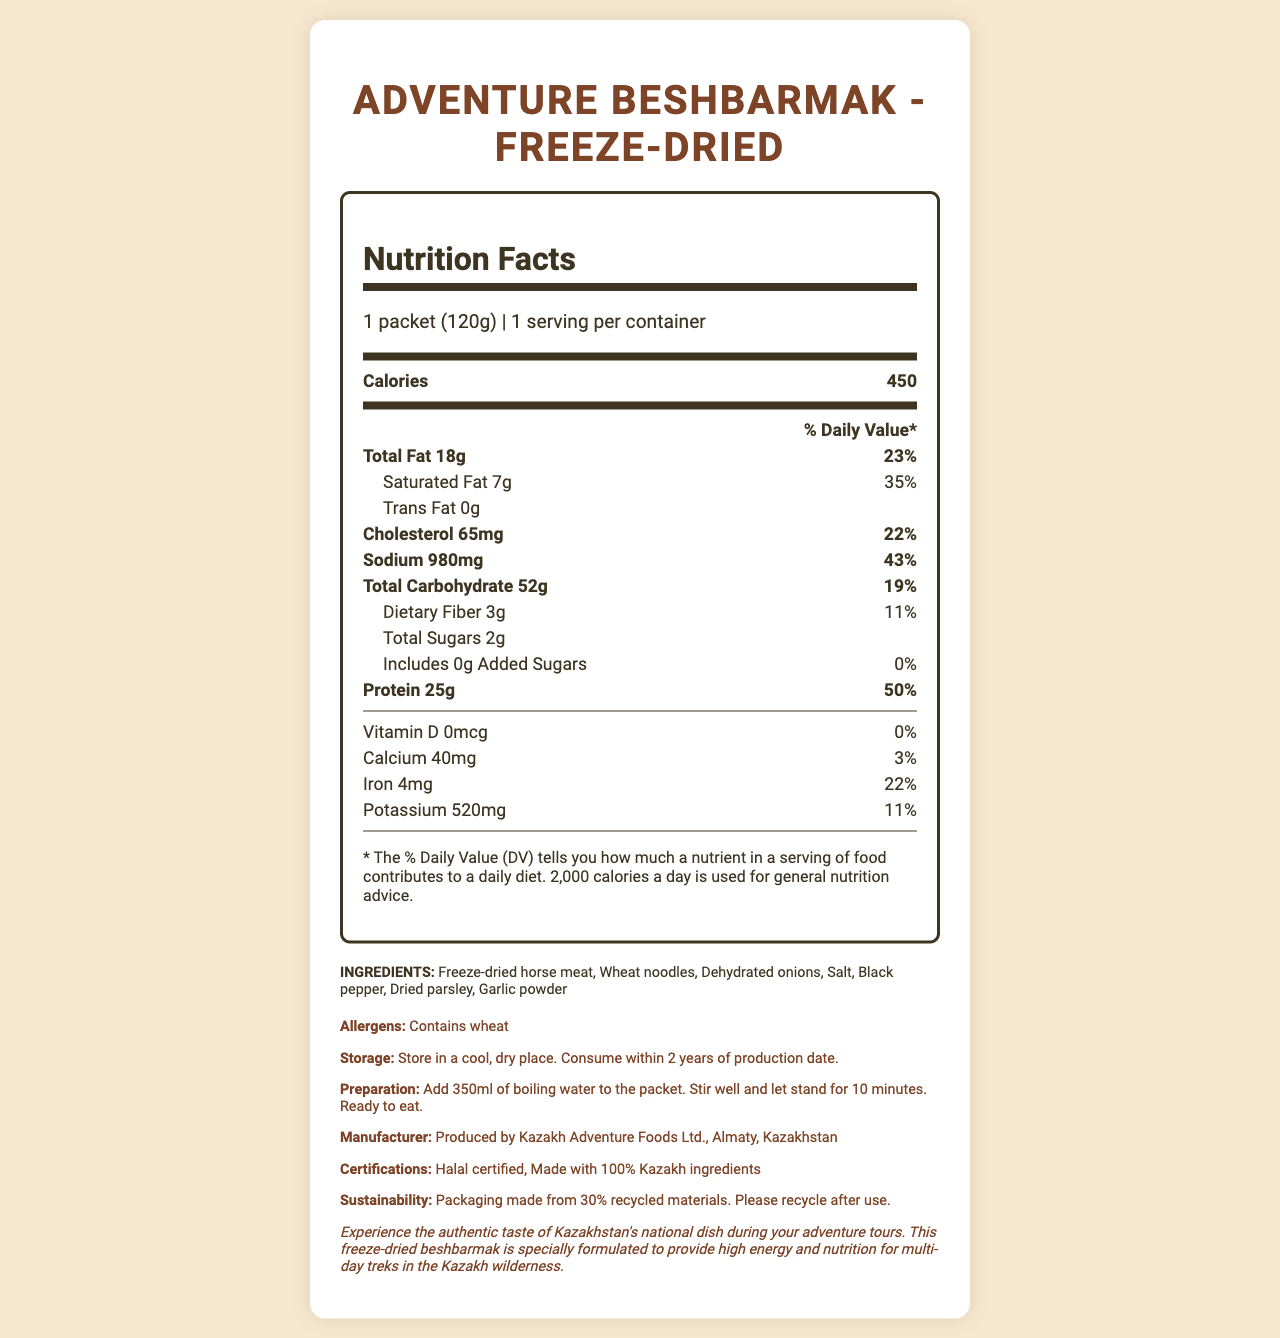what is the serving size of the freeze-dried beshbarmak packet? The serving size is explicitly mentioned under the "serving-info" section at the top of the Nutrition Facts label.
Answer: 1 packet (120g) How many calories are in one serving of this product? The number of calories per serving is listed immediately after the serving size and servings per container in the Nutrition Facts section.
Answer: 450 What is the percentage of the daily value of saturated fat in one serving? The % daily value of saturated fat is listed in the Nutrient Facts section under the "Saturated Fat" sub-nutrient, which is indented below "Total Fat."
Answer: 35% What ingredients are used in this product? The ingredients list is provided in the "INGREDIENTS" section towards the bottom of the document.
Answer: Freeze-dried horse meat, Wheat noodles, Dehydrated onions, Salt, Black pepper, Dried parsley, Garlic powder How much protein does one serving contain? The amount of protein per serving is listed in the Nutrient Facts section under the "Protein" main-nutrient.
Answer: 25g What is the percentage of the daily value for sodium in one serving? The % daily value for sodium is straightforwardly mentioned in the Nutrient Facts section under the "Sodium" main-nutrient.
Answer: 43% Is this product Halal certified? (Yes/No) The certification section at the bottom of the document lists "Halal certified."
Answer: Yes What is the main source of protein in this product? The ingredients list reveals that the primary ingredient, freeze-dried horse meat, is the main source of protein.
Answer: Freeze-dried horse meat Which vitamin listed has a 0% daily value? The Nutrient Facts lists Vitamin D with a 0% daily value next to its amount.
Answer: Vitamin D Which of the following nutrients has the highest daily value percentage in one serving?
A. Iron
B. Protein
C. Calcium
D. Sodium The daily value percentages listed show that Protein is 50%, which is the highest among the options.
Answer: B. Protein What is the recommended preparation method for this freeze-dried beshbarmak packet?
A. Bake at 350°F for 20 minutes
B. Microwave for 2 minutes
C. Add 350ml boiling water, stir, and let stand for 10 minutes The preparation instructions clearly state this method.
Answer: C. Add 350ml boiling water, stir, and let stand for 10 minutes Which nutrient has the least amount per serving?
A. Vitamin D
B. Trans Fat
C. Sodium
D. Total Sugars Even though both Trans Fat and Vitamin D have "zero," per serving Vitamin D is explicitly stated as "0 mcg," confirming it's absence more definitively compared to "0 g" Trans Fat.
Answer: A. Vitamin D Would an individual with a wheat allergy be able to consume this product? The allergens section clearly states "Contains wheat."
Answer: No Describe the entire document. The document conveys vital nutritional and logistical information about freeze-dried beshbarmak for informed consumer choices during adventure tours.
Answer: This document is a Nutrition Facts label for "Adventure Beshbarmak - Freeze-Dried," a product designed for multi-day adventure tours. It includes essential nutritional information, calorie count, list of ingredients, allergens, storage and preparation instructions, manufacturer details, and certifications. It emphasizes the usage of authentic Kazakh ingredients and sustainability efforts of the packaging. What is the expiration period for this product from the production date? The storage instructions specify that the product should be consumed within 2 years of the production date.
Answer: 2 years Is there any information about the vitamin B12 content of this product in the label? The document does not mention vitamin B12 content, making it unanswerable based on the available visual information.
Answer: Not enough information 